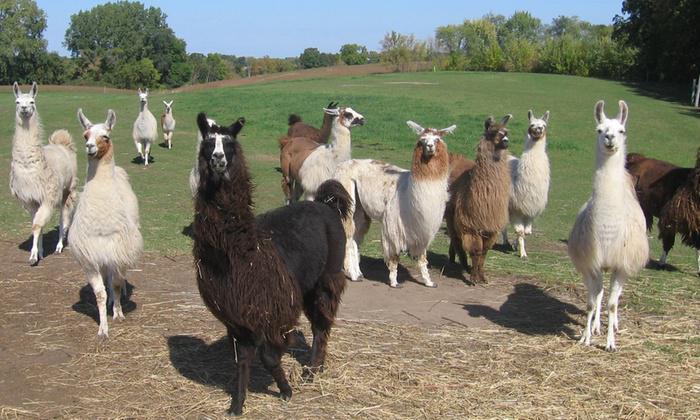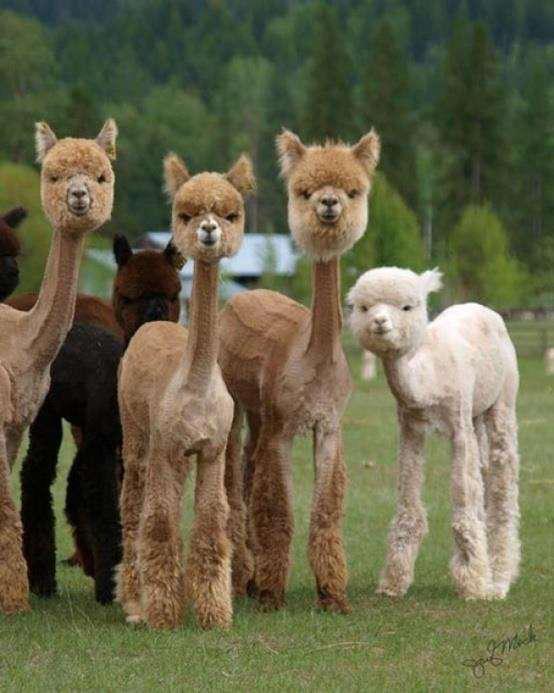The first image is the image on the left, the second image is the image on the right. Considering the images on both sides, is "One image shows a group of at least five llamas with rounded heads and fur in various solid colors standing and facing forward." valid? Answer yes or no. Yes. 